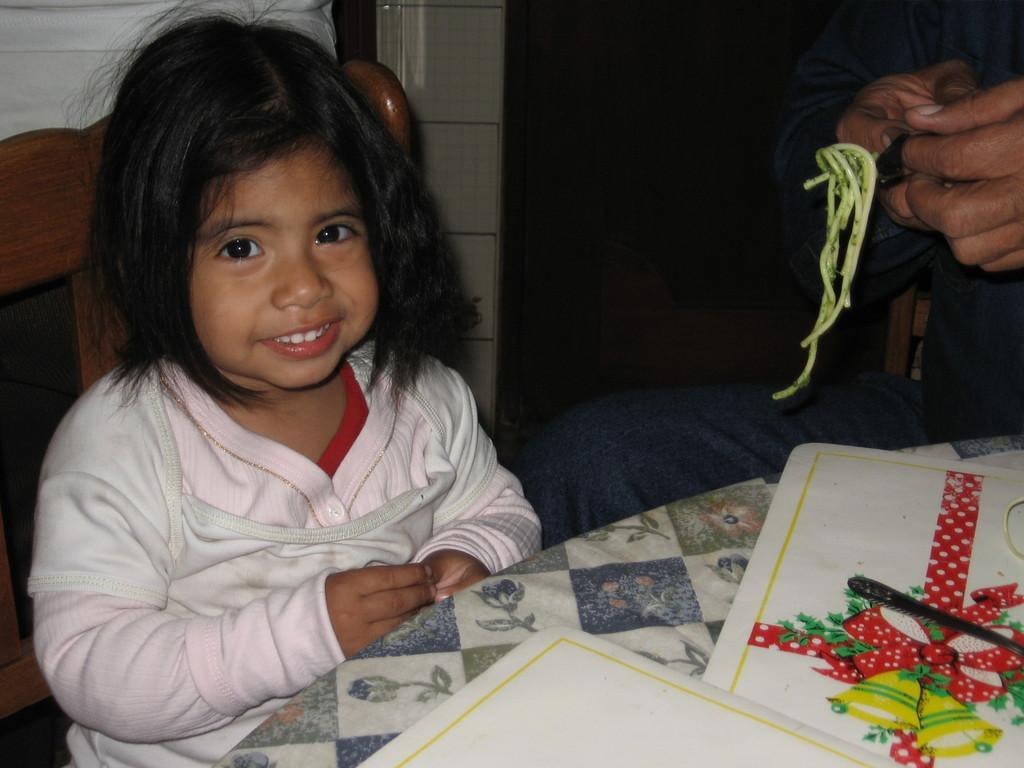How would you summarize this image in a sentence or two? In this image, we can see a kid sitting on the chair and there is a man holding a fork and some food item. At the bottom, there are some papers and a spoon are on the table. 